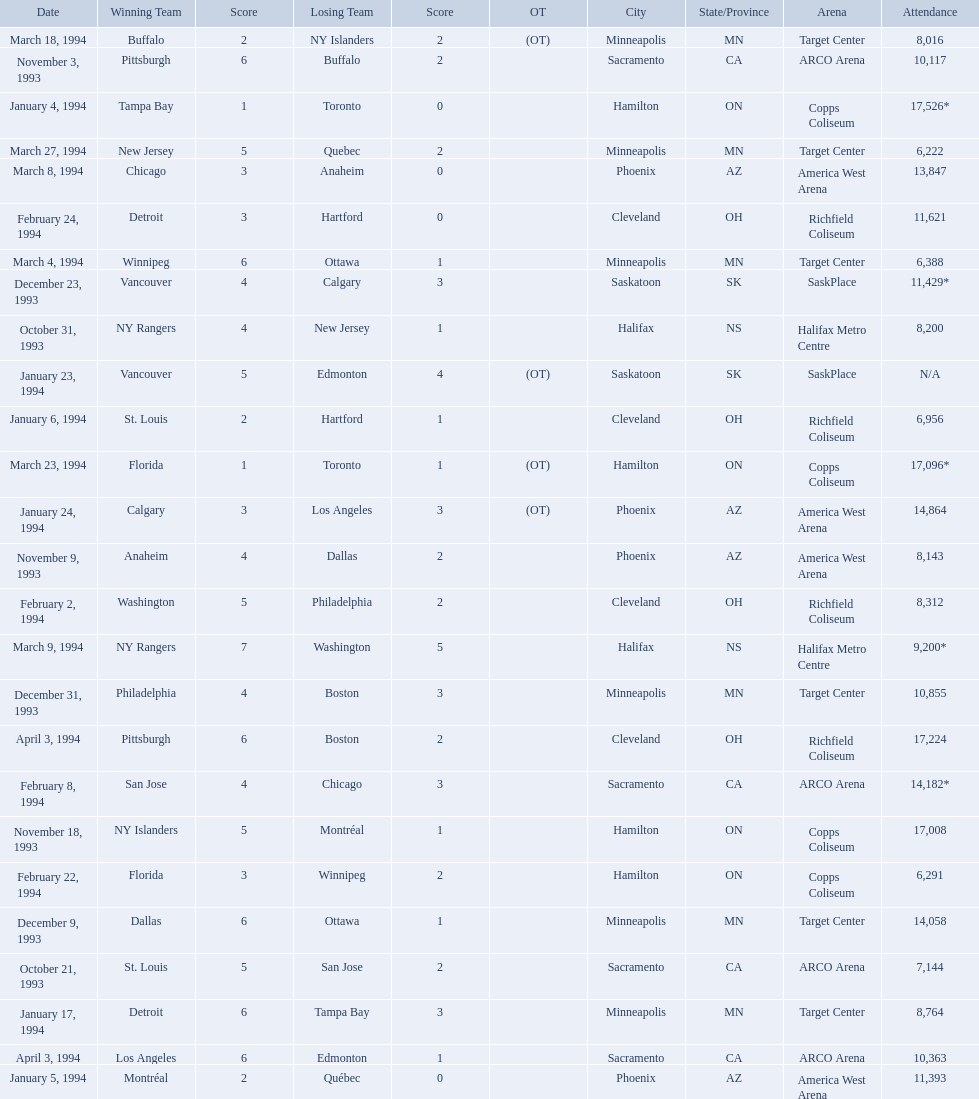When were the games played? October 21, 1993, October 31, 1993, November 3, 1993, November 9, 1993, November 18, 1993, December 9, 1993, December 23, 1993, December 31, 1993, January 4, 1994, January 5, 1994, January 6, 1994, January 17, 1994, January 23, 1994, January 24, 1994, February 2, 1994, February 8, 1994, February 22, 1994, February 24, 1994, March 4, 1994, March 8, 1994, March 9, 1994, March 18, 1994, March 23, 1994, March 27, 1994, April 3, 1994, April 3, 1994. What was the attendance for those games? 7,144, 8,200, 10,117, 8,143, 17,008, 14,058, 11,429*, 10,855, 17,526*, 11,393, 6,956, 8,764, N/A, 14,864, 8,312, 14,182*, 6,291, 11,621, 6,388, 13,847, 9,200*, 8,016, 17,096*, 6,222, 17,224, 10,363. Which date had the highest attendance? January 4, 1994. 